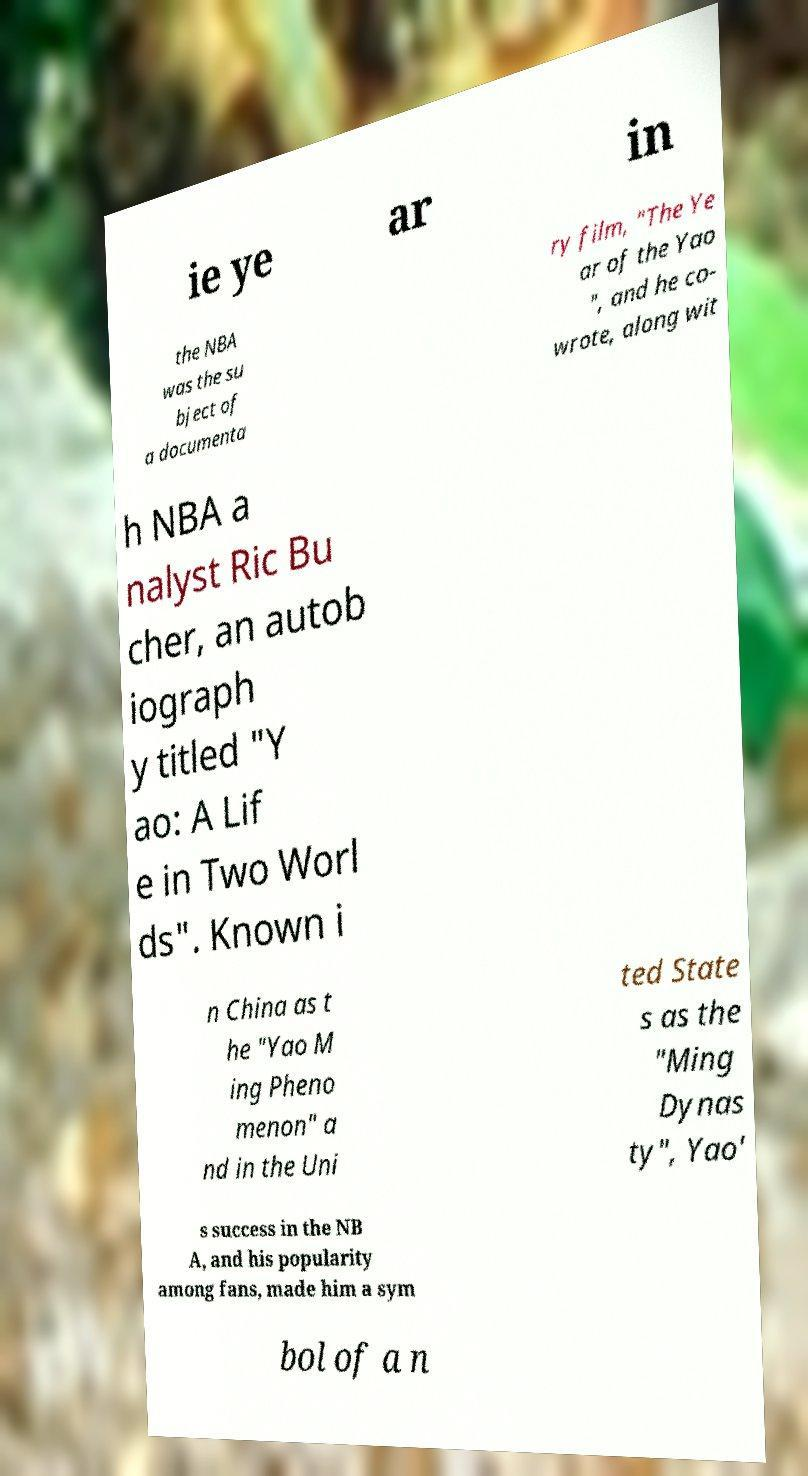Can you accurately transcribe the text from the provided image for me? ie ye ar in the NBA was the su bject of a documenta ry film, "The Ye ar of the Yao ", and he co- wrote, along wit h NBA a nalyst Ric Bu cher, an autob iograph y titled "Y ao: A Lif e in Two Worl ds". Known i n China as t he "Yao M ing Pheno menon" a nd in the Uni ted State s as the "Ming Dynas ty", Yao' s success in the NB A, and his popularity among fans, made him a sym bol of a n 